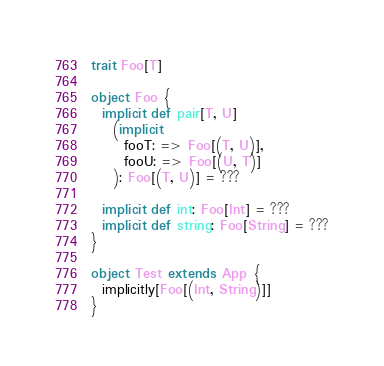<code> <loc_0><loc_0><loc_500><loc_500><_Scala_>trait Foo[T]

object Foo {
  implicit def pair[T, U]
    (implicit
      fooT: => Foo[(T, U)],
      fooU: => Foo[(U, T)]
    ): Foo[(T, U)] = ???

  implicit def int: Foo[Int] = ???
  implicit def string: Foo[String] = ???
}

object Test extends App {
  implicitly[Foo[(Int, String)]]
}
</code> 